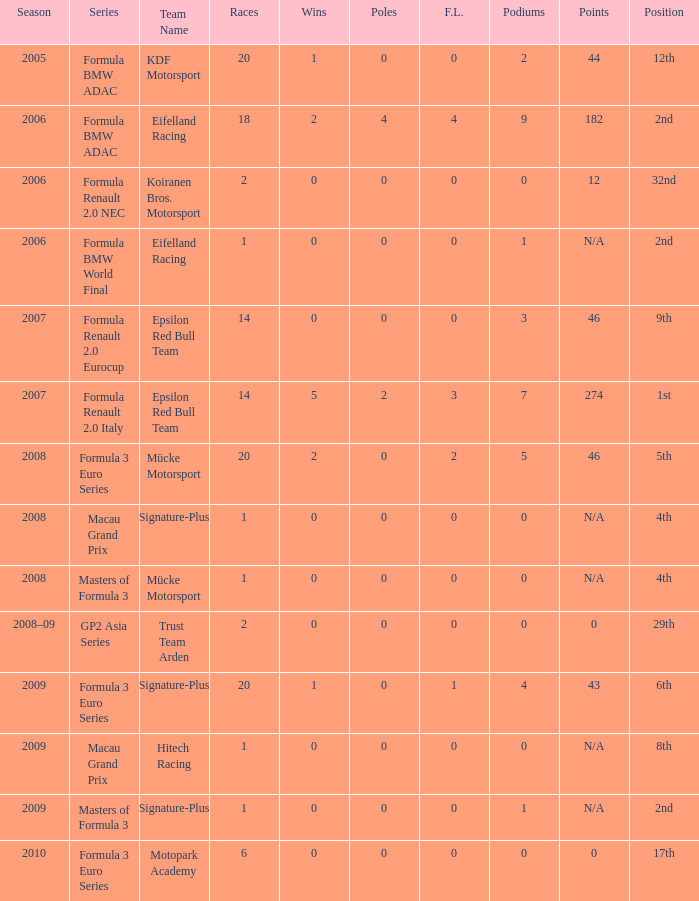What is the race in the 8th position? 1.0. 